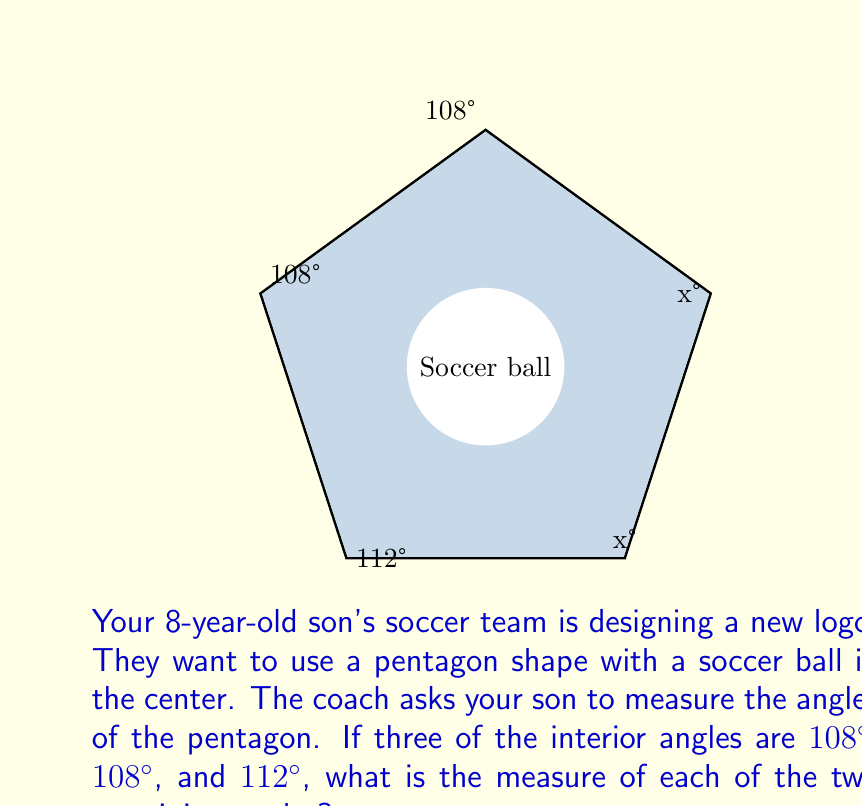Teach me how to tackle this problem. Let's approach this step-by-step:

1) First, recall that the sum of interior angles of a pentagon is given by the formula:
   $$(n-2) \times 180^\circ$$
   where $n$ is the number of sides. For a pentagon, $n = 5$.

2) Let's calculate the sum of interior angles:
   $$(5-2) \times 180^\circ = 3 \times 180^\circ = 540^\circ$$

3) We know three of the angles: $108^\circ$, $108^\circ$, and $112^\circ$. Let's call each of the unknown angles $x$.

4) We can set up an equation:
   $$108^\circ + 108^\circ + 112^\circ + x + x = 540^\circ$$

5) Simplify:
   $$328^\circ + 2x = 540^\circ$$

6) Subtract $328^\circ$ from both sides:
   $$2x = 212^\circ$$

7) Divide both sides by 2:
   $$x = 106^\circ$$

Therefore, each of the two remaining angles measures $106^\circ$.
Answer: $106^\circ$ 